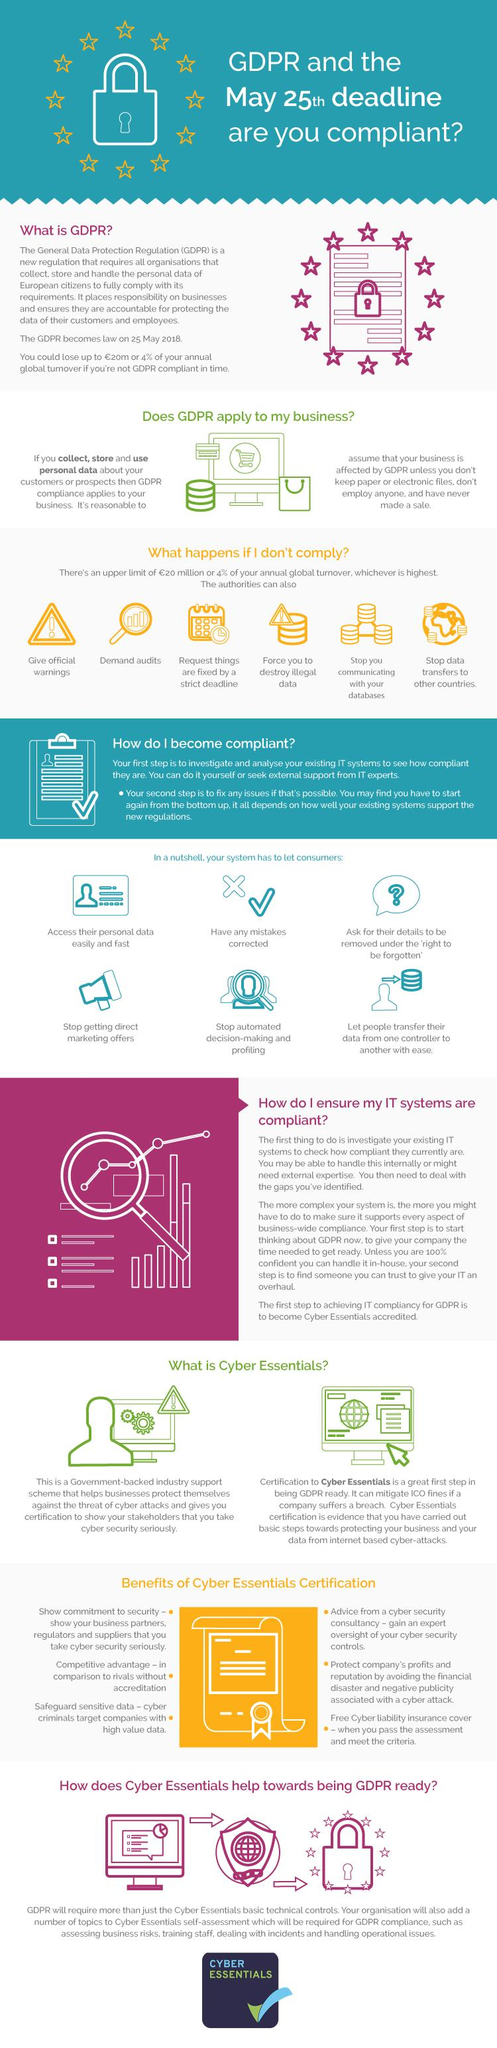Specify some key components in this picture. The number of bullet points under the benefits of Cyber Essentials certification is six. The punctuation mark shown in the triangle is the exclamation mark. The color of the cyber essential certificate in the image is yellow. The government-backed Cyber Essentials scheme provides assistance to businesses in protecting themselves from cyber attacks. By when are businesses expected to be GDPR compliant? May 25, 2018. 